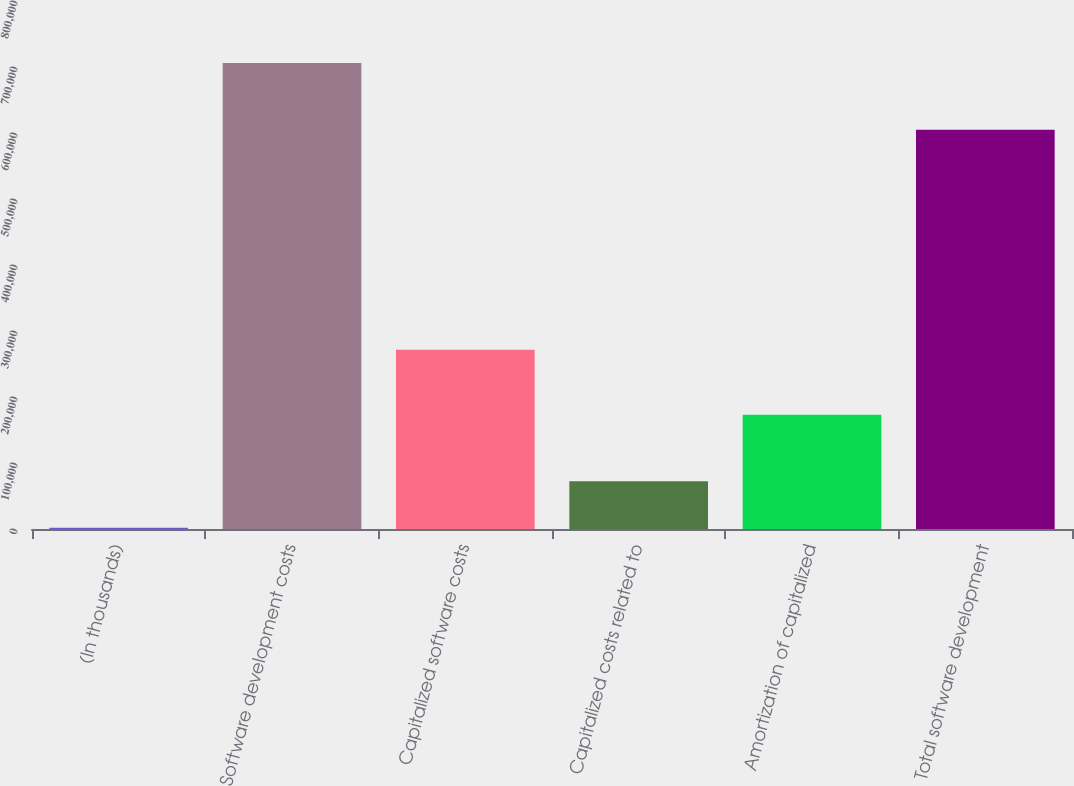<chart> <loc_0><loc_0><loc_500><loc_500><bar_chart><fcel>(In thousands)<fcel>Software development costs<fcel>Capitalized software costs<fcel>Capitalized costs related to<fcel>Amortization of capitalized<fcel>Total software development<nl><fcel>2017<fcel>705944<fcel>271411<fcel>72409.7<fcel>173250<fcel>605046<nl></chart> 